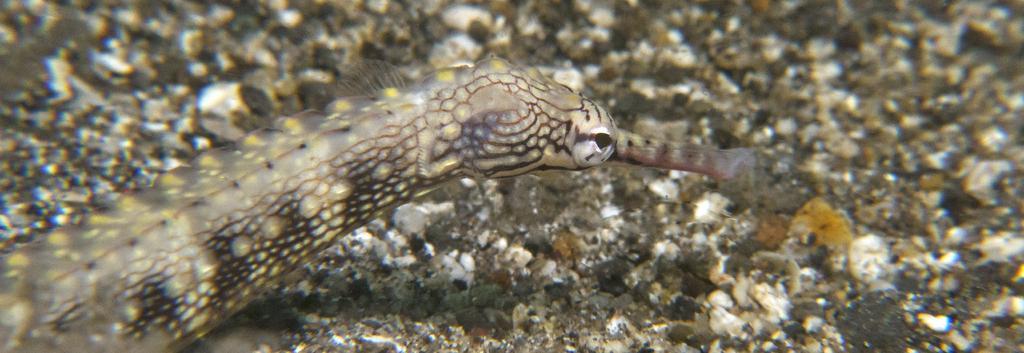In one or two sentences, can you explain what this image depicts? This is a zoomed in picture. On the left there is a reptile seems to be a snake. In the background we can see the gravels. 